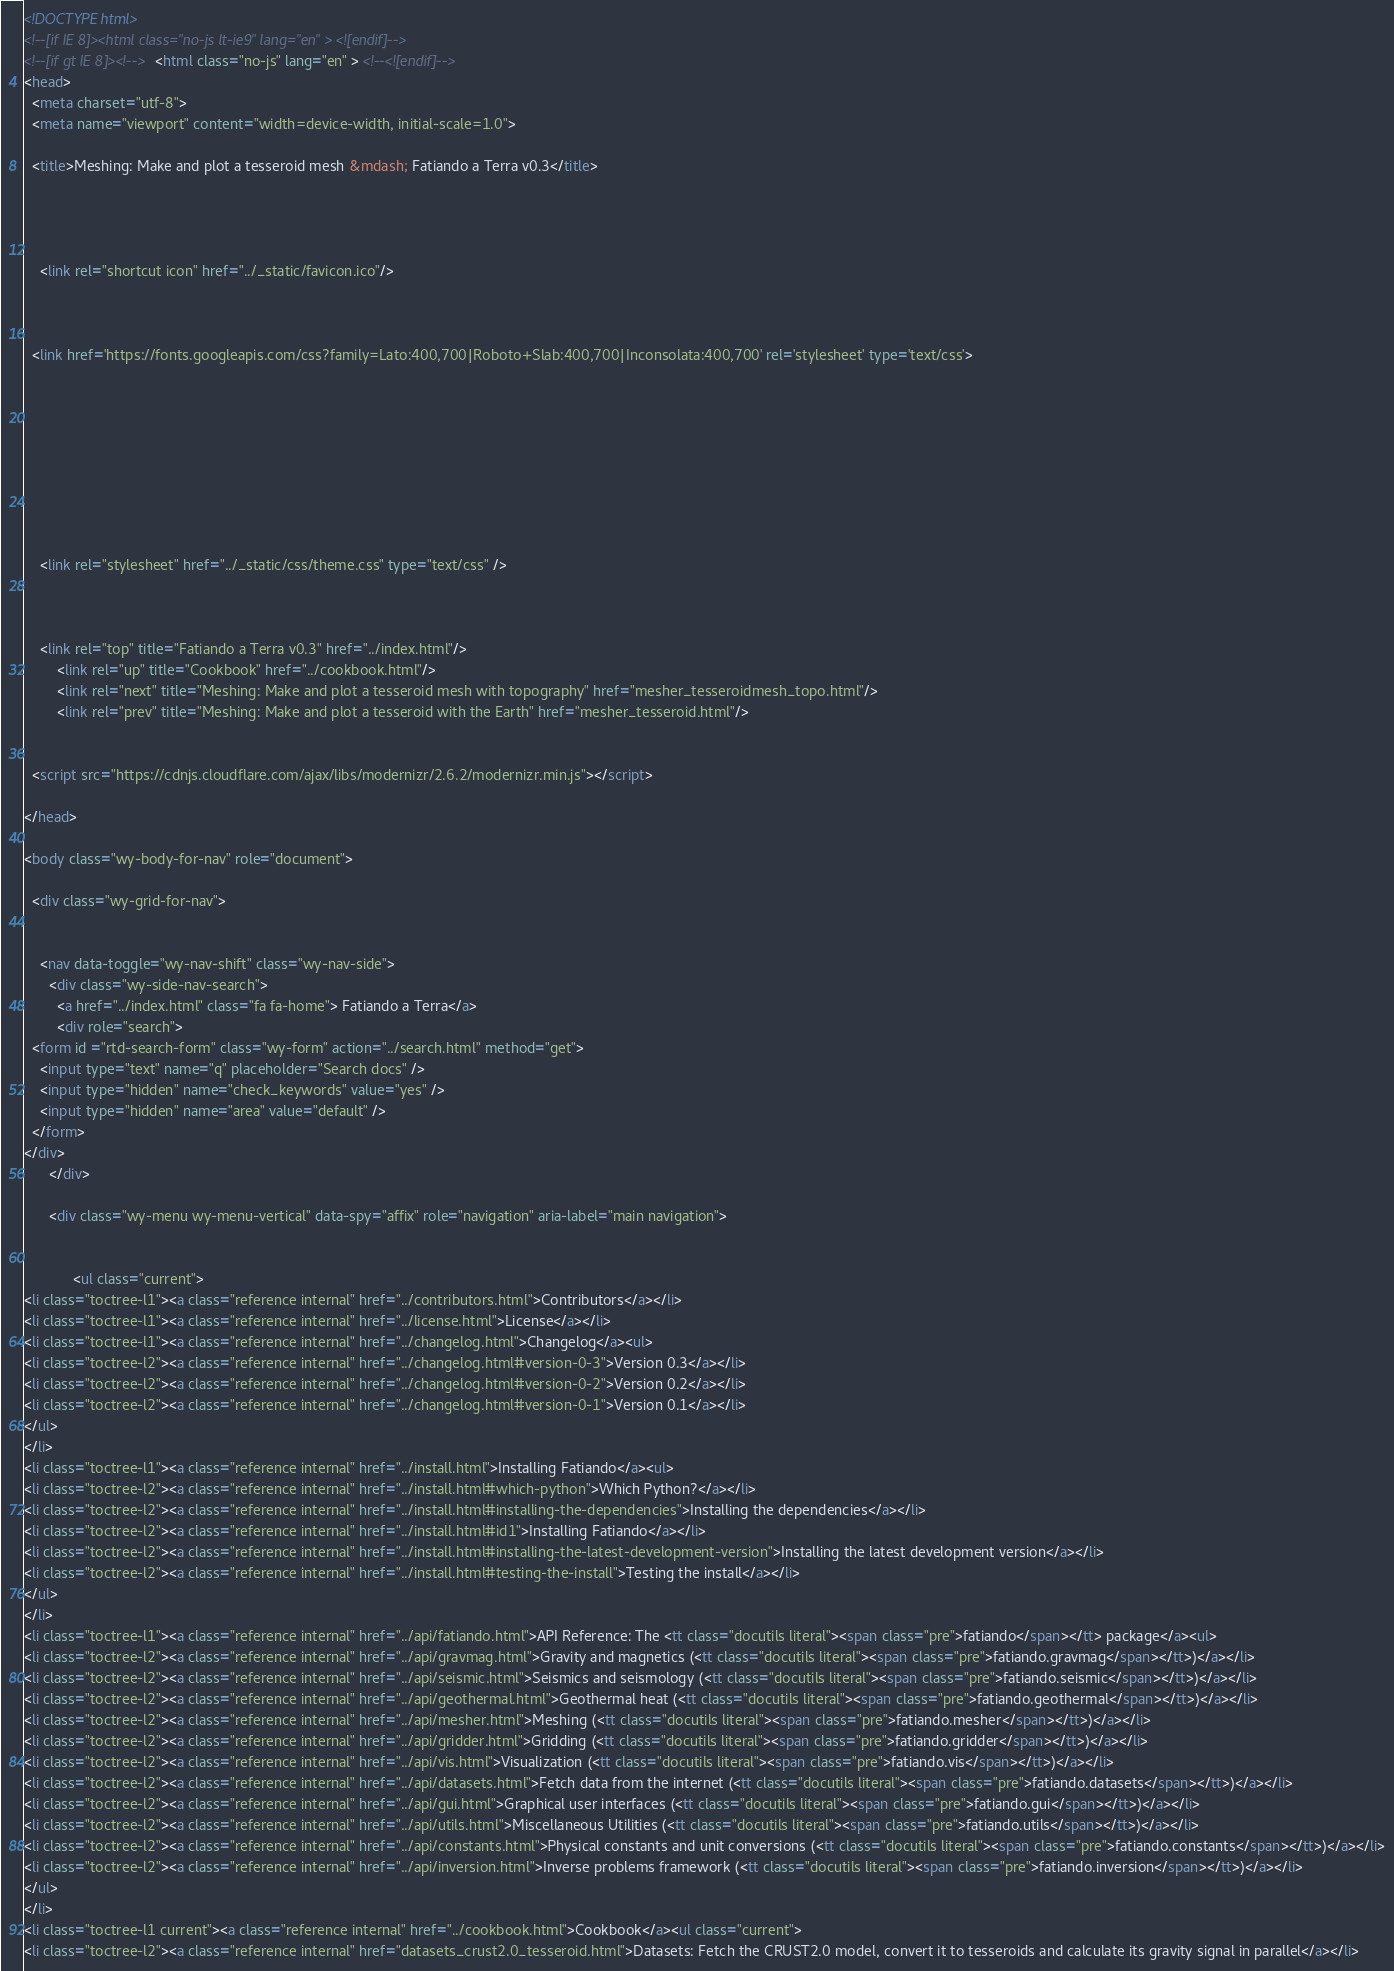Convert code to text. <code><loc_0><loc_0><loc_500><loc_500><_HTML_>

<!DOCTYPE html>
<!--[if IE 8]><html class="no-js lt-ie9" lang="en" > <![endif]-->
<!--[if gt IE 8]><!--> <html class="no-js" lang="en" > <!--<![endif]-->
<head>
  <meta charset="utf-8">
  <meta name="viewport" content="width=device-width, initial-scale=1.0">
  
  <title>Meshing: Make and plot a tesseroid mesh &mdash; Fatiando a Terra v0.3</title>
  

  
  
    <link rel="shortcut icon" href="../_static/favicon.ico"/>
  

  
  <link href='https://fonts.googleapis.com/css?family=Lato:400,700|Roboto+Slab:400,700|Inconsolata:400,700' rel='stylesheet' type='text/css'>

  
  
    

  

  
  
    <link rel="stylesheet" href="../_static/css/theme.css" type="text/css" />
  

  
    <link rel="top" title="Fatiando a Terra v0.3" href="../index.html"/>
        <link rel="up" title="Cookbook" href="../cookbook.html"/>
        <link rel="next" title="Meshing: Make and plot a tesseroid mesh with topography" href="mesher_tesseroidmesh_topo.html"/>
        <link rel="prev" title="Meshing: Make and plot a tesseroid with the Earth" href="mesher_tesseroid.html"/> 

  
  <script src="https://cdnjs.cloudflare.com/ajax/libs/modernizr/2.6.2/modernizr.min.js"></script>

</head>

<body class="wy-body-for-nav" role="document">

  <div class="wy-grid-for-nav">

    
    <nav data-toggle="wy-nav-shift" class="wy-nav-side">
      <div class="wy-side-nav-search">
        <a href="../index.html" class="fa fa-home"> Fatiando a Terra</a>
        <div role="search">
  <form id ="rtd-search-form" class="wy-form" action="../search.html" method="get">
    <input type="text" name="q" placeholder="Search docs" />
    <input type="hidden" name="check_keywords" value="yes" />
    <input type="hidden" name="area" value="default" />
  </form>
</div>
      </div>

      <div class="wy-menu wy-menu-vertical" data-spy="affix" role="navigation" aria-label="main navigation">
        
        
            <ul class="current">
<li class="toctree-l1"><a class="reference internal" href="../contributors.html">Contributors</a></li>
<li class="toctree-l1"><a class="reference internal" href="../license.html">License</a></li>
<li class="toctree-l1"><a class="reference internal" href="../changelog.html">Changelog</a><ul>
<li class="toctree-l2"><a class="reference internal" href="../changelog.html#version-0-3">Version 0.3</a></li>
<li class="toctree-l2"><a class="reference internal" href="../changelog.html#version-0-2">Version 0.2</a></li>
<li class="toctree-l2"><a class="reference internal" href="../changelog.html#version-0-1">Version 0.1</a></li>
</ul>
</li>
<li class="toctree-l1"><a class="reference internal" href="../install.html">Installing Fatiando</a><ul>
<li class="toctree-l2"><a class="reference internal" href="../install.html#which-python">Which Python?</a></li>
<li class="toctree-l2"><a class="reference internal" href="../install.html#installing-the-dependencies">Installing the dependencies</a></li>
<li class="toctree-l2"><a class="reference internal" href="../install.html#id1">Installing Fatiando</a></li>
<li class="toctree-l2"><a class="reference internal" href="../install.html#installing-the-latest-development-version">Installing the latest development version</a></li>
<li class="toctree-l2"><a class="reference internal" href="../install.html#testing-the-install">Testing the install</a></li>
</ul>
</li>
<li class="toctree-l1"><a class="reference internal" href="../api/fatiando.html">API Reference: The <tt class="docutils literal"><span class="pre">fatiando</span></tt> package</a><ul>
<li class="toctree-l2"><a class="reference internal" href="../api/gravmag.html">Gravity and magnetics (<tt class="docutils literal"><span class="pre">fatiando.gravmag</span></tt>)</a></li>
<li class="toctree-l2"><a class="reference internal" href="../api/seismic.html">Seismics and seismology (<tt class="docutils literal"><span class="pre">fatiando.seismic</span></tt>)</a></li>
<li class="toctree-l2"><a class="reference internal" href="../api/geothermal.html">Geothermal heat (<tt class="docutils literal"><span class="pre">fatiando.geothermal</span></tt>)</a></li>
<li class="toctree-l2"><a class="reference internal" href="../api/mesher.html">Meshing (<tt class="docutils literal"><span class="pre">fatiando.mesher</span></tt>)</a></li>
<li class="toctree-l2"><a class="reference internal" href="../api/gridder.html">Gridding (<tt class="docutils literal"><span class="pre">fatiando.gridder</span></tt>)</a></li>
<li class="toctree-l2"><a class="reference internal" href="../api/vis.html">Visualization (<tt class="docutils literal"><span class="pre">fatiando.vis</span></tt>)</a></li>
<li class="toctree-l2"><a class="reference internal" href="../api/datasets.html">Fetch data from the internet (<tt class="docutils literal"><span class="pre">fatiando.datasets</span></tt>)</a></li>
<li class="toctree-l2"><a class="reference internal" href="../api/gui.html">Graphical user interfaces (<tt class="docutils literal"><span class="pre">fatiando.gui</span></tt>)</a></li>
<li class="toctree-l2"><a class="reference internal" href="../api/utils.html">Miscellaneous Utilities (<tt class="docutils literal"><span class="pre">fatiando.utils</span></tt>)</a></li>
<li class="toctree-l2"><a class="reference internal" href="../api/constants.html">Physical constants and unit conversions (<tt class="docutils literal"><span class="pre">fatiando.constants</span></tt>)</a></li>
<li class="toctree-l2"><a class="reference internal" href="../api/inversion.html">Inverse problems framework (<tt class="docutils literal"><span class="pre">fatiando.inversion</span></tt>)</a></li>
</ul>
</li>
<li class="toctree-l1 current"><a class="reference internal" href="../cookbook.html">Cookbook</a><ul class="current">
<li class="toctree-l2"><a class="reference internal" href="datasets_crust2.0_tesseroid.html">Datasets: Fetch the CRUST2.0 model, convert it to tesseroids and calculate its gravity signal in parallel</a></li></code> 